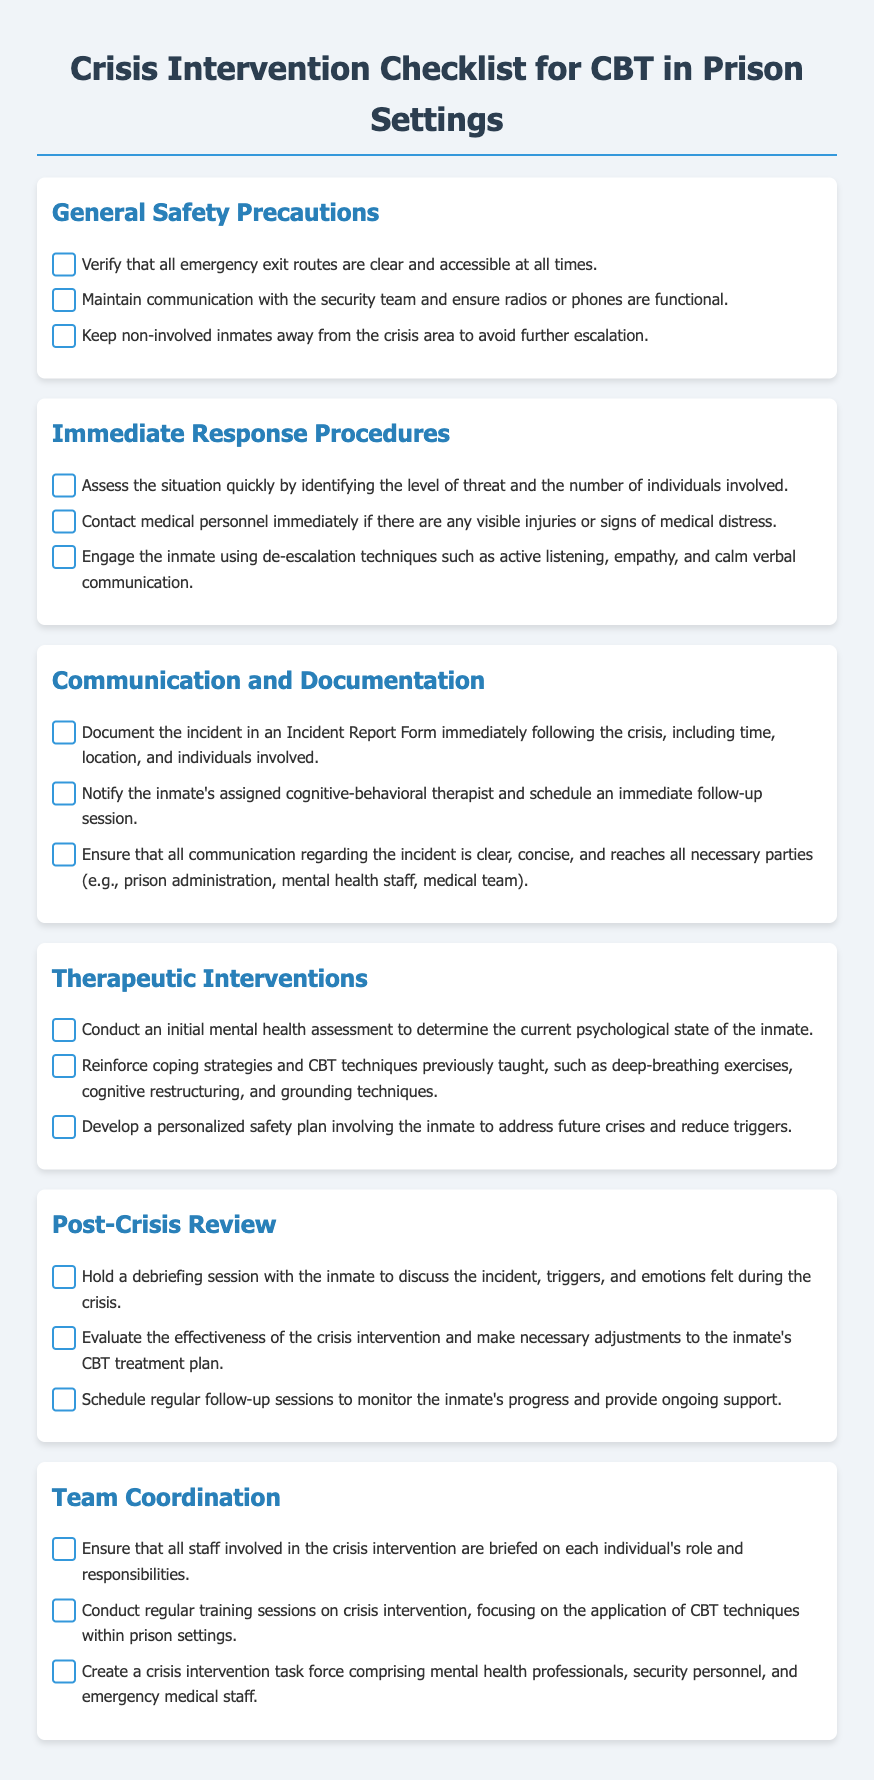What are the names of the sections in the checklist? The sections in the checklist are General Safety Precautions, Immediate Response Procedures, Communication and Documentation, Therapeutic Interventions, Post-Crisis Review, and Team Coordination.
Answer: General Safety Precautions, Immediate Response Procedures, Communication and Documentation, Therapeutic Interventions, Post-Crisis Review, Team Coordination How many items are listed under Immediate Response Procedures? There are three items listed under Immediate Response Procedures.
Answer: 3 What should be documented immediately following a crisis? The incident must be documented in an Incident Report Form, including time, location, and individuals involved.
Answer: Incident Report Form What is the purpose of holding a debriefing session with the inmate? The purpose of holding a debriefing session is to discuss the incident, triggers, and emotions felt during the crisis.
Answer: Discuss the incident, triggers, and emotions What should be reinforced to the inmate after a crisis? Coping strategies and CBT techniques previously taught should be reinforced.
Answer: Coping strategies and CBT techniques How many roles should be briefed to the staff involved in the crisis intervention? All staff involved should be briefed on each individual's role and responsibilities.
Answer: Each individual's role and responsibilities What is the focus of the regular training sessions conducted? The focus of the training sessions is on crisis intervention, especially the application of CBT techniques within prison settings.
Answer: Application of CBT techniques What is a key aspect of developing a personalized safety plan? The key aspect is to involve the inmate to address future crises and reduce triggers.
Answer: Involve the inmate to address future crises and reduce triggers 